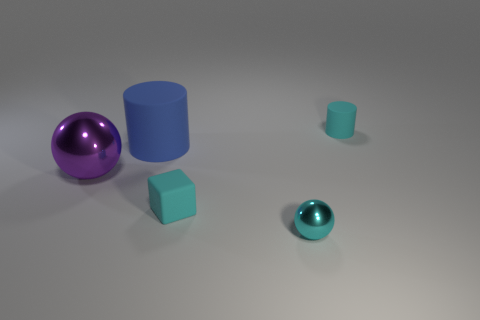There is a small matte object in front of the big cylinder; does it have the same color as the small shiny ball?
Offer a terse response. Yes. There is a small rubber object that is behind the cyan matte block; are there any large purple metallic objects that are left of it?
Offer a very short reply. Yes. Is the number of tiny cyan cylinders that are in front of the purple shiny ball less than the number of tiny matte cubes on the right side of the small cyan ball?
Keep it short and to the point. No. How big is the cylinder in front of the tiny matte object that is to the right of the small cyan cube in front of the purple ball?
Provide a succinct answer. Large. There is a metallic object that is behind the cyan metal object; is its size the same as the big cylinder?
Offer a very short reply. Yes. How many other objects are the same material as the tiny cyan sphere?
Ensure brevity in your answer.  1. Are there more big blue matte objects than matte cylinders?
Keep it short and to the point. No. What is the material of the ball behind the tiny cyan block that is in front of the matte cylinder behind the large cylinder?
Make the answer very short. Metal. Is the color of the tiny rubber block the same as the tiny shiny sphere?
Offer a very short reply. Yes. Is there a shiny ball of the same color as the tiny cylinder?
Offer a very short reply. Yes. 